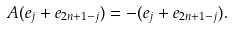Convert formula to latex. <formula><loc_0><loc_0><loc_500><loc_500>A ( e _ { j } + e _ { 2 n + 1 - j } ) = - ( e _ { j } + e _ { 2 n + 1 - j } ) .</formula> 